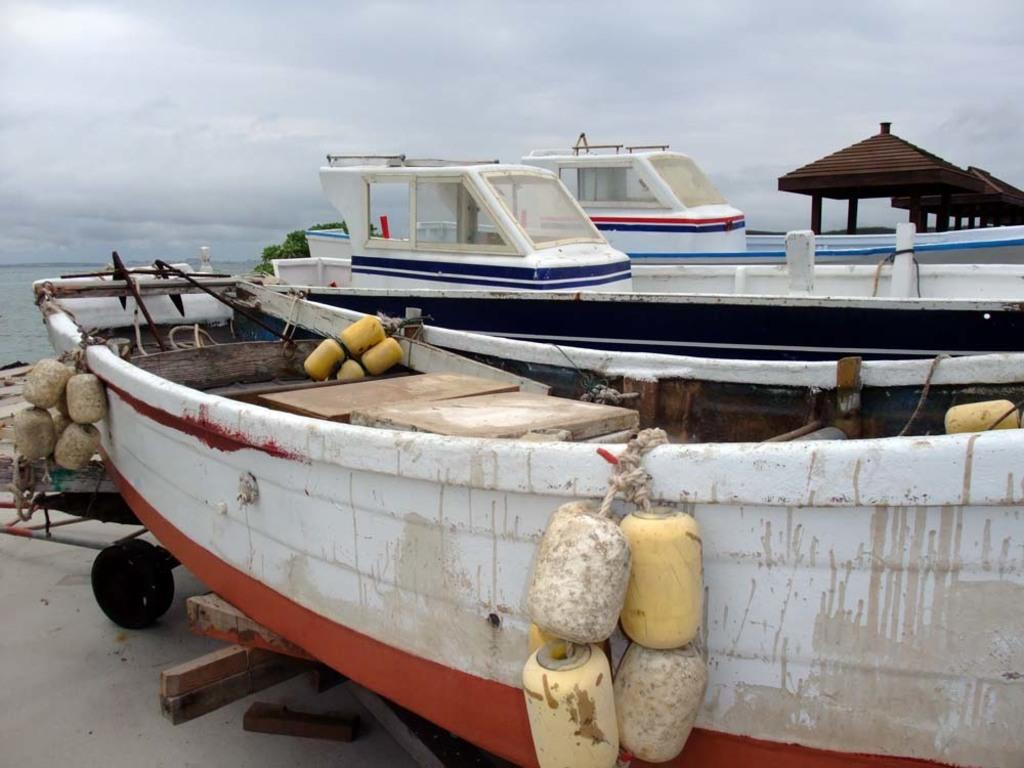What objects are on the trolley on the floor in the image? There are boats on a trolley on the floor in the image. What can be seen on the left side of the image? There is a sea on the left side of the image. What is visible above the sea in the image? The sky is visible above the sea in the image. What can be observed in the sky in the image? Clouds are present in the sky in the image. Where is the desk located in the image? There is no desk present in the image. What type of birth can be observed in the image? There is no birth depicted in the image. 